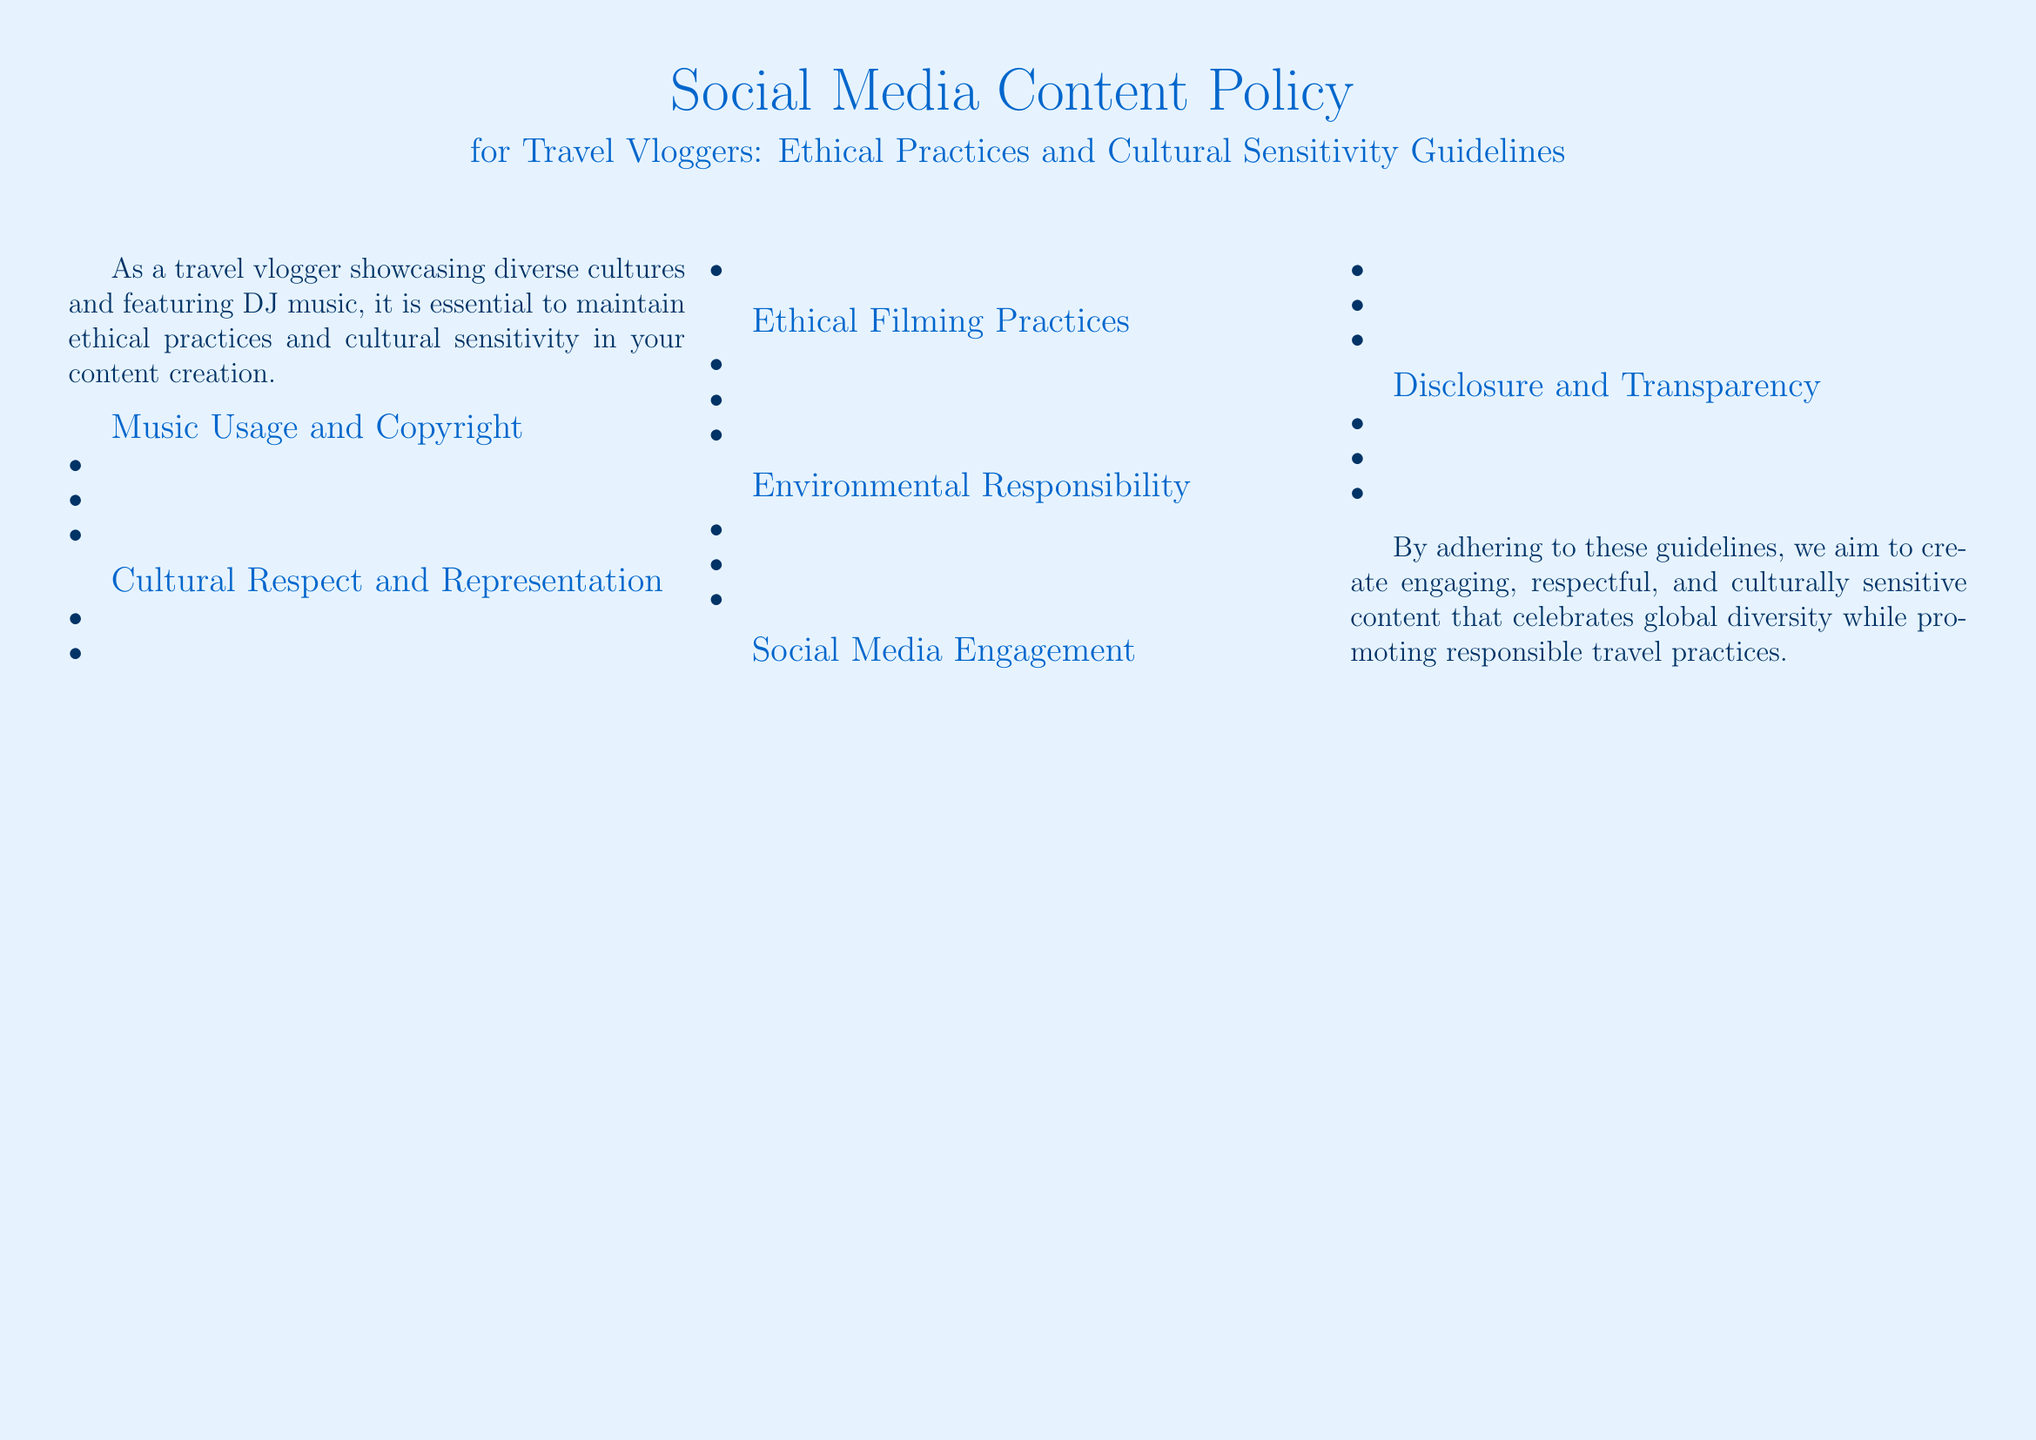What is the title of the document? The title is prominently displayed at the top of the document and reads, "Social Media Content Policy for Travel Vloggers: Ethical Practices and Cultural Sensitivity Guidelines."
Answer: Social Media Content Policy for Travel Vloggers: Ethical Practices and Cultural Sensitivity Guidelines How many sections are in the document? The document includes six distinct sections outlining guidelines for travel vloggers.
Answer: 6 What is the first guideline under "Music Usage and Copyright"? This guideline addresses the use of DJ music and is mentioned at the top of the list for that section.
Answer: Always obtain proper licensing for DJ music What does the document advise regarding local customs? The document specifies the importance of understanding local cultures and highlights the necessity to research these aspects.
Answer: Research local customs and traditions What principle should be followed to promote environmental responsibility? The document emphasizes sustainable practices for travel, specifically mentioning this principle directly related to responsible travel.
Answer: Follow 'Leave No Trace' principles What is the suggested behavior for engaging with comments on social media? The document outlines expectations for how travel vloggers should interact with their audience in a respectful manner.
Answer: Respond to comments respectfully What should vloggers do before filming sacred sites? The document clearly states the importance of obtaining permission in this sensitive context.
Answer: Seek permission before filming sacred sites According to the guidelines, who should be credited alongside the music used? The document emphasizes the ethical practice of acknowledging the contributions of artists in the content.
Answer: The DJs and musicians What is the closing statement of the document about? The closing statement reflects the purpose of the guidelines in creating meaningful and respectful content while promoting good travel practices.
Answer: Engaging, respectful, and culturally sensitive content 